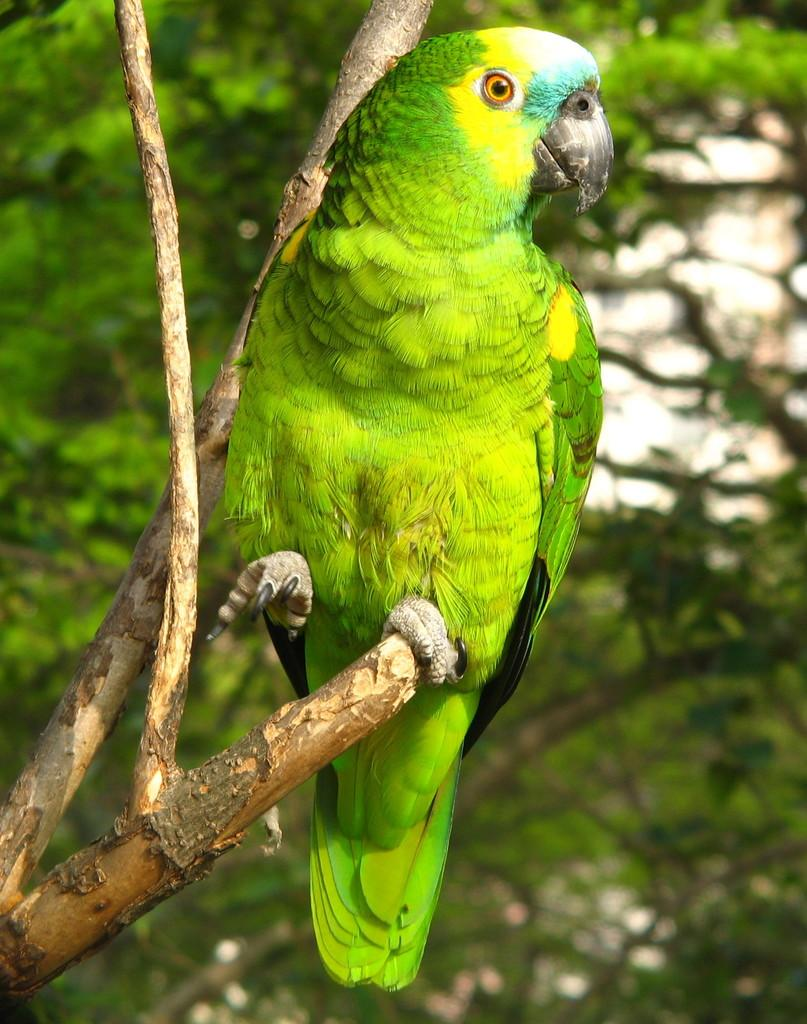What type of animal is in the image? There is a parrot in the image. Where is the parrot located? The parrot is on a branch. What can be seen in the background of the image? There are trees in the background of the image. How many apples are hanging from the branch the parrot is sitting on? There are no apples present in the image; it only features a parrot on a branch and trees in the background. 